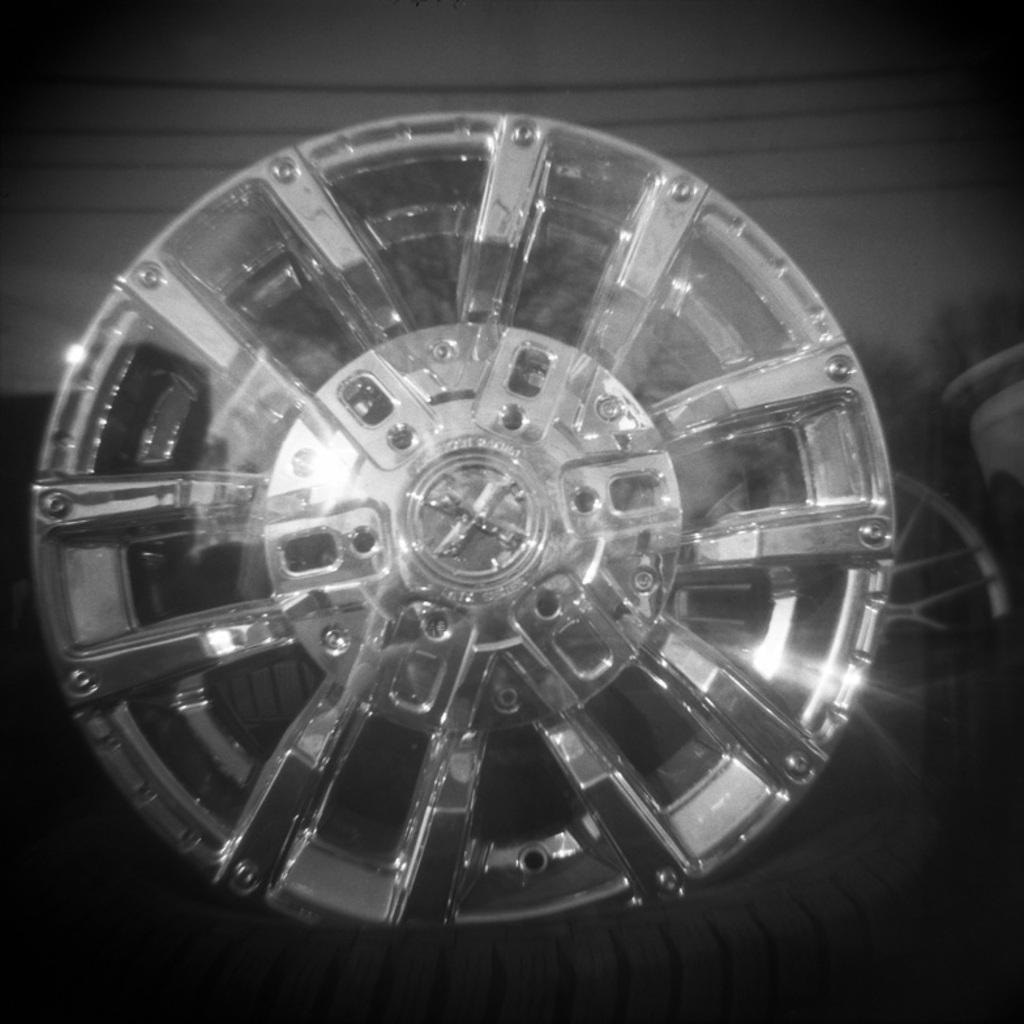What is the shape of the object that resembles a wheel in the image? The object that looks like a wheel in the image is round. What color is the object in the background of the image? The object in the background of the image is white. What can be found on the ground in the image? There are objects on the ground in the image. What nation does the creator of the wheel belong to in the image? There is no information about the creator of the wheel in the image, nor is there any indication of a nation. 